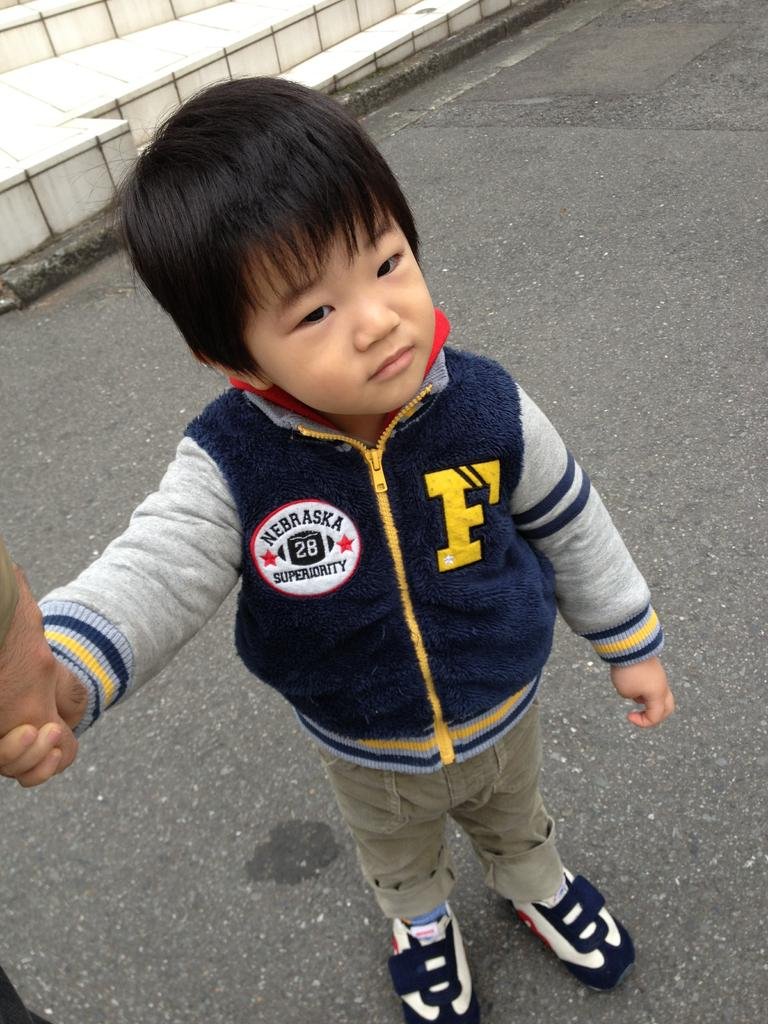<image>
Provide a brief description of the given image. A young boy wears a jacket with a Nebraska patch on it. 